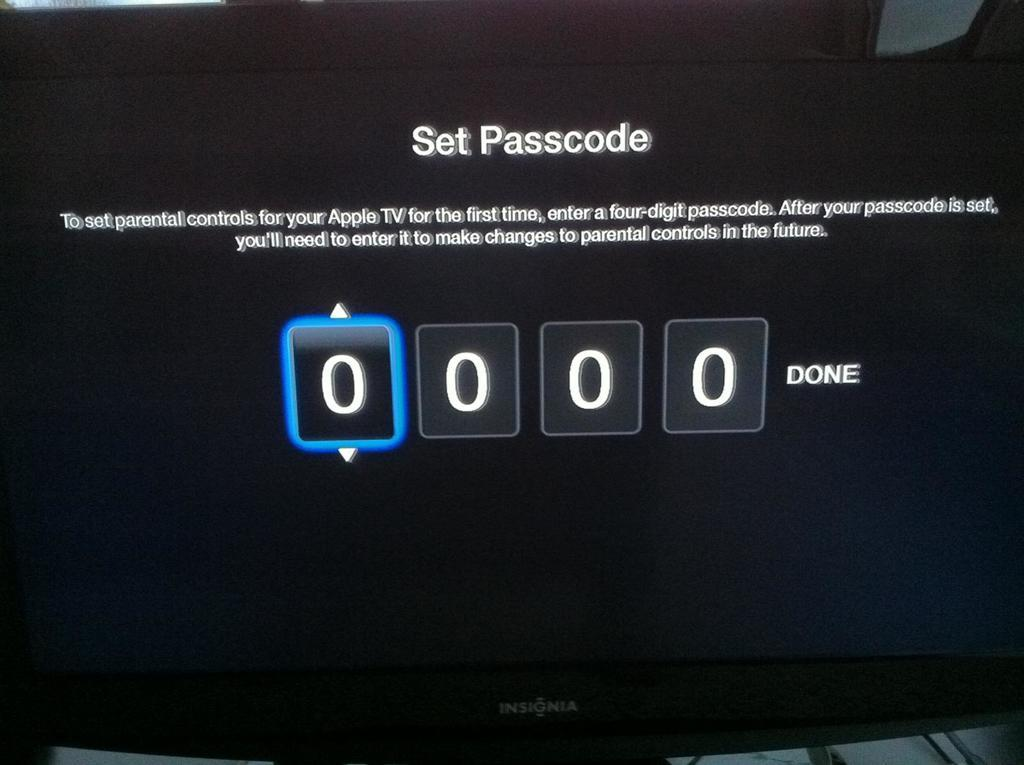<image>
Relay a brief, clear account of the picture shown. The apple tv needs a passcode to be entered to work. 